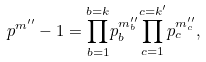Convert formula to latex. <formula><loc_0><loc_0><loc_500><loc_500>p ^ { m ^ { \prime \prime } } - 1 = { \prod _ { b = 1 } ^ { b = k } } p _ { b } ^ { m _ { b } ^ { \prime \prime } } { \prod _ { c = 1 } ^ { c = k ^ { \prime } } } p _ { c } ^ { m _ { c } ^ { \prime \prime } } ,</formula> 